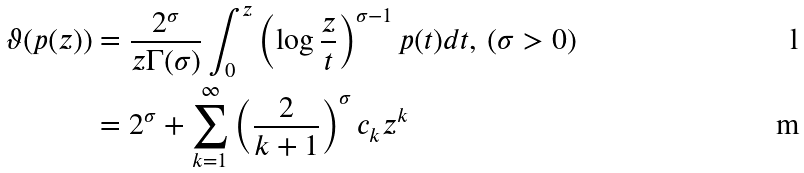<formula> <loc_0><loc_0><loc_500><loc_500>\vartheta ( p ( z ) ) & = \frac { 2 ^ { \sigma } } { z \Gamma ( \sigma ) } \int _ { 0 } ^ { z } \left ( \log \frac { z } { t } \right ) ^ { \sigma - 1 } p ( t ) d t , \, ( \sigma > 0 ) \\ & = 2 ^ { \sigma } + \sum _ { k = 1 } ^ { \infty } \left ( \frac { 2 } { k + 1 } \right ) ^ { \sigma } c _ { k } z ^ { k }</formula> 